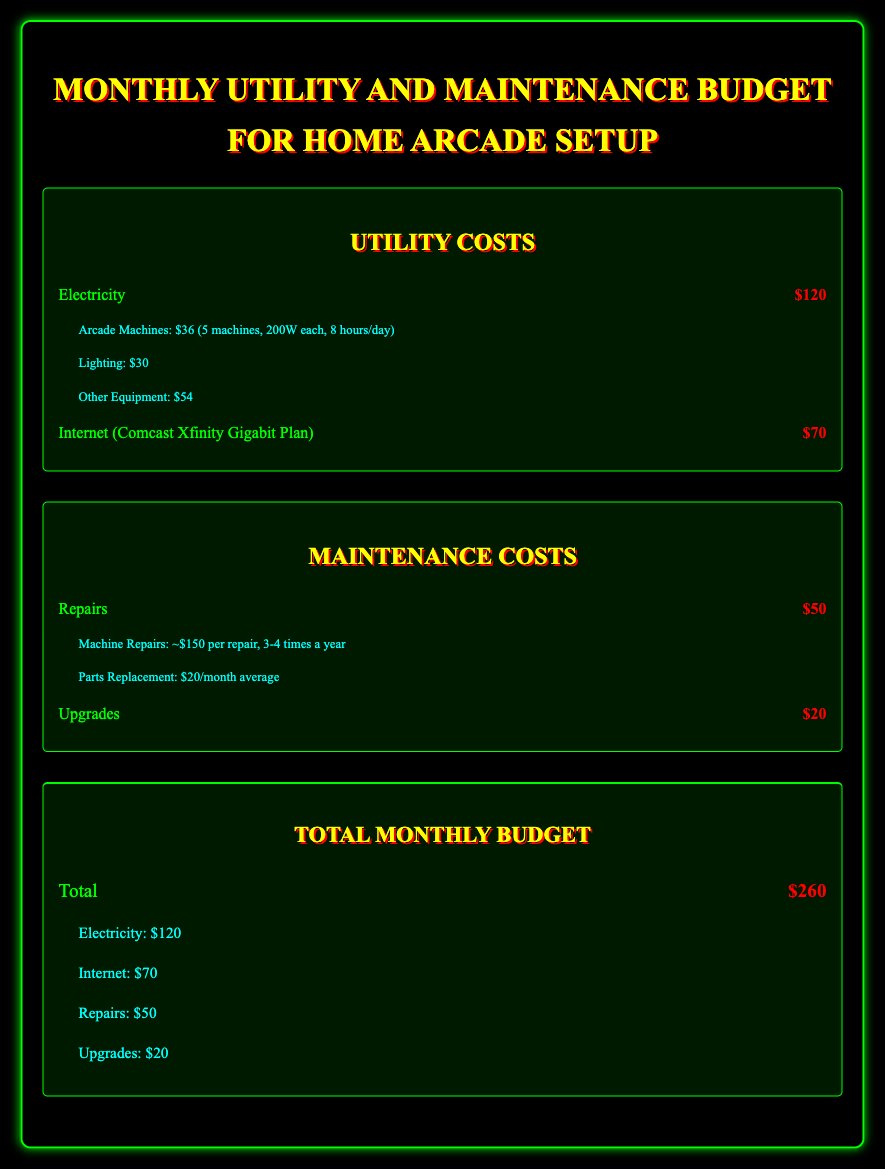What is the total monthly budget? The total monthly budget is the sum of all utility and maintenance costs listed in the document, which totals $260.
Answer: $260 How much is spent on electricity? The document states that the electricity cost specifically for the arcade setup is $120.
Answer: $120 What is the cost of internet service? The document mentions the internet cost as $70 for the Comcast Xfinity Gigabit Plan.
Answer: $70 How many arcade machines are considered in the electricity cost? The details in the document indicate that there are 5 arcade machines contributing to the electricity cost calculation.
Answer: 5 What is the average cost of parts replacement per month? The details indicate that the average monthly cost for parts replacement is $20.
Answer: $20 What is the repair cost listed in the maintenance section? The document specifies that the repair cost is $50 per month.
Answer: $50 How much is allocated for upgrades? The budget document states that $20 is allocated for upgrades each month.
Answer: $20 What is the estimated cost per machine repair? According to the details, the average cost of machine repairs is approximately $150 per repair.
Answer: $150 What is the total cost of lighting in utility costs? The document lists the lighting cost as $30 within the utility section.
Answer: $30 